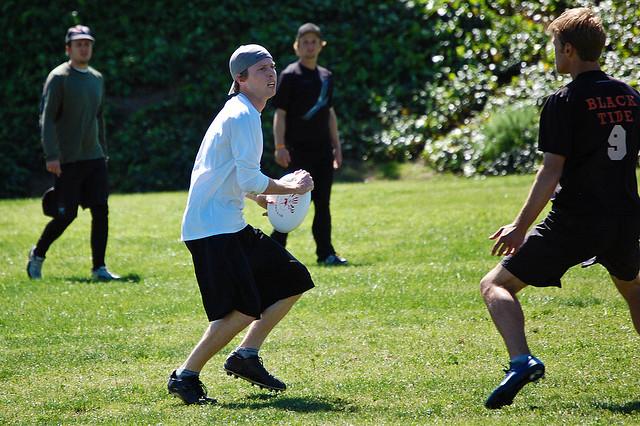How many men are wearing white shirts?
Give a very brief answer. 1. Are they playing American football?
Concise answer only. No. What type of shoes are the men wearing?
Keep it brief. Cleats. 